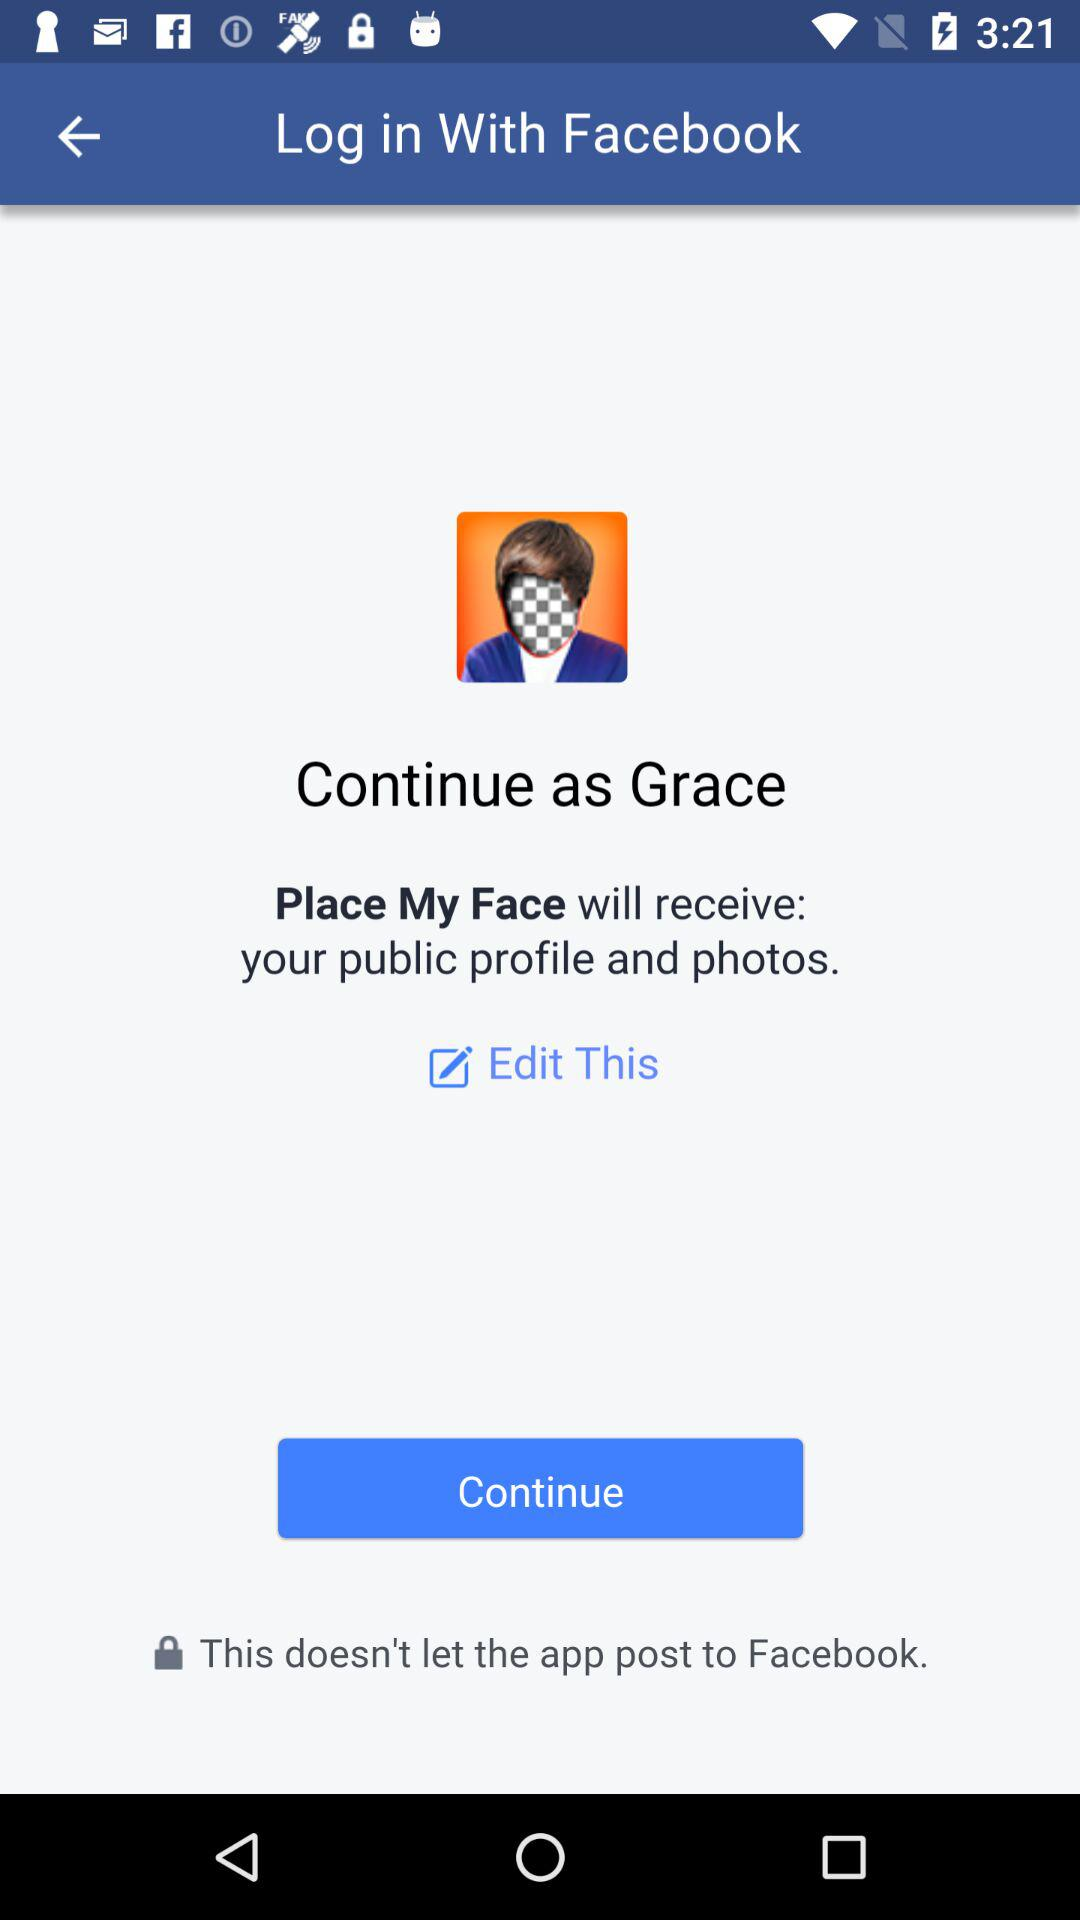What is Grace's last name?
When the provided information is insufficient, respond with <no answer>. <no answer> 